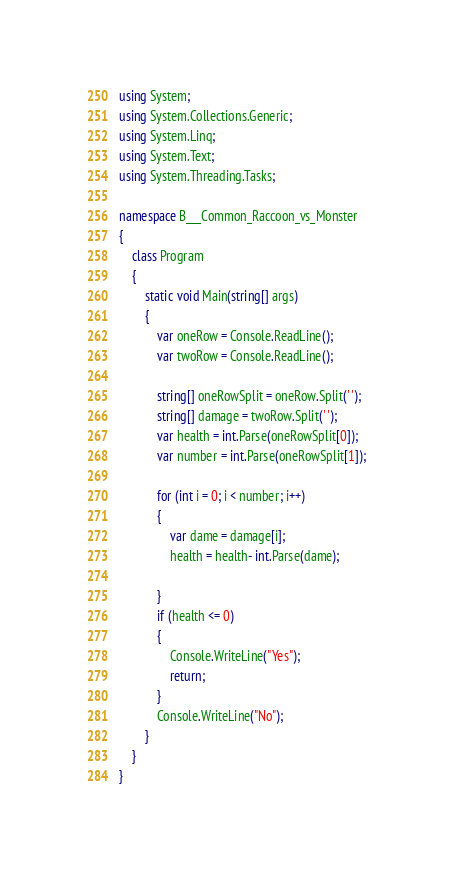<code> <loc_0><loc_0><loc_500><loc_500><_C#_>using System;
using System.Collections.Generic;
using System.Linq;
using System.Text;
using System.Threading.Tasks;

namespace B___Common_Raccoon_vs_Monster
{
    class Program
    {
        static void Main(string[] args)
        {
            var oneRow = Console.ReadLine();
            var twoRow = Console.ReadLine();

            string[] oneRowSplit = oneRow.Split(' ');
            string[] damage = twoRow.Split(' ');
            var health = int.Parse(oneRowSplit[0]);
            var number = int.Parse(oneRowSplit[1]);

            for (int i = 0; i < number; i++)
            {
                var dame = damage[i];
                health = health- int.Parse(dame);

            }
            if (health <= 0)
            {
                Console.WriteLine("Yes");
                return;
            }
            Console.WriteLine("No");
        }
    }
}
</code> 